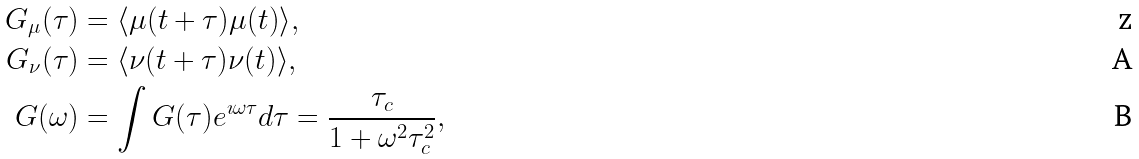Convert formula to latex. <formula><loc_0><loc_0><loc_500><loc_500>G _ { \mu } ( \tau ) & = \langle \mu ( t + \tau ) \mu ( t ) \rangle , \\ G _ { \nu } ( \tau ) & = \langle \nu ( t + \tau ) \nu ( t ) \rangle , \\ G ( \omega ) & = \int G ( \tau ) e ^ { \imath \omega \tau } d \tau = \frac { \tau _ { c } } { 1 + \omega ^ { 2 } \tau _ { c } ^ { 2 } } ,</formula> 